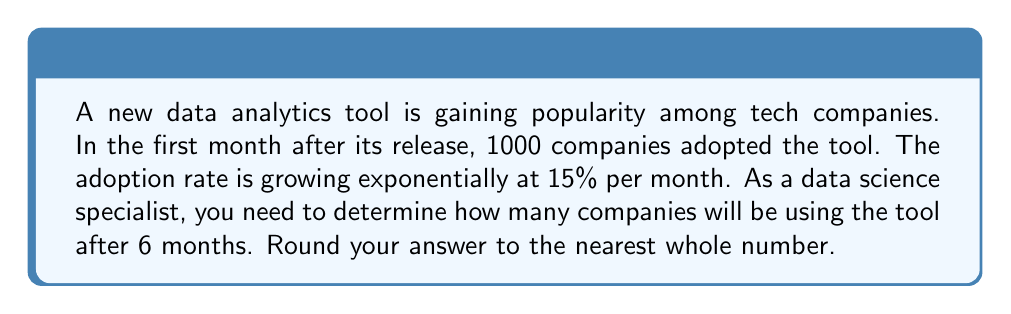Show me your answer to this math problem. Let's approach this step-by-step:

1) The initial number of companies (at month 0) is 1000.

2) The monthly growth rate is 15% or 0.15.

3) We can use the exponential growth formula:
   $$A = P(1 + r)^t$$
   Where:
   $A$ = final amount
   $P$ = initial amount (1000)
   $r$ = growth rate (0.15)
   $t$ = time period (6 months)

4) Plugging in our values:
   $$A = 1000(1 + 0.15)^6$$

5) Let's calculate:
   $$A = 1000(1.15)^6$$
   $$A = 1000(2.3131)$$
   $$A = 2313.1$$

6) Rounding to the nearest whole number:
   $$A ≈ 2313$$
Answer: 2313 companies 